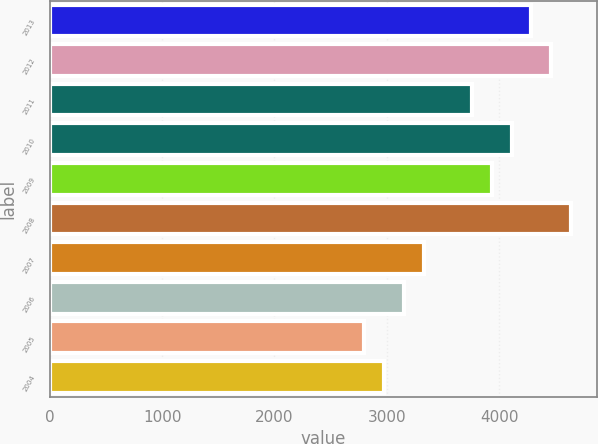Convert chart. <chart><loc_0><loc_0><loc_500><loc_500><bar_chart><fcel>2013<fcel>2012<fcel>2011<fcel>2010<fcel>2009<fcel>2008<fcel>2007<fcel>2006<fcel>2005<fcel>2004<nl><fcel>4286.9<fcel>4463.2<fcel>3758<fcel>4110.6<fcel>3934.3<fcel>4639.5<fcel>3329.9<fcel>3153.6<fcel>2801<fcel>2977.3<nl></chart> 